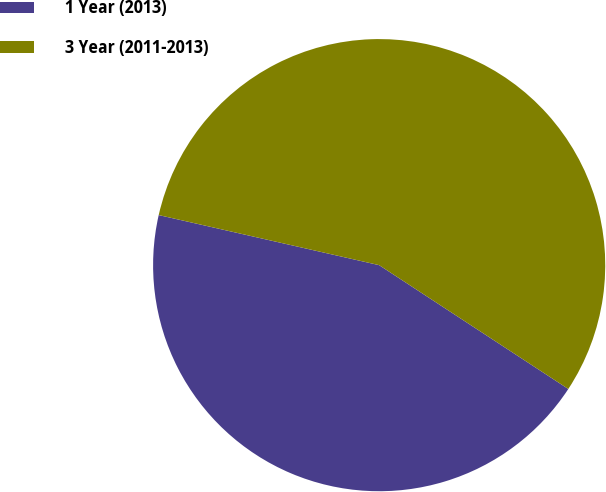Convert chart. <chart><loc_0><loc_0><loc_500><loc_500><pie_chart><fcel>1 Year (2013)<fcel>3 Year (2011-2013)<nl><fcel>44.33%<fcel>55.67%<nl></chart> 